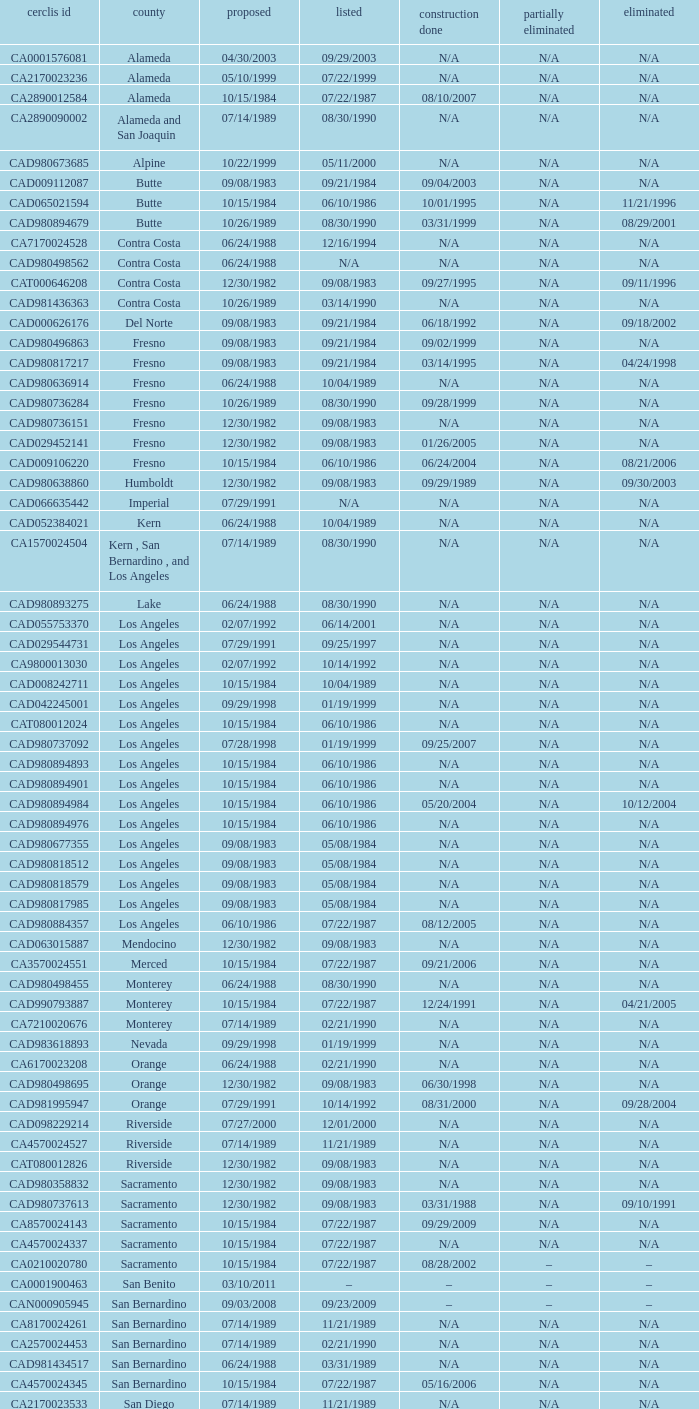What construction completed on 08/10/2007? 07/22/1987. 